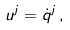<formula> <loc_0><loc_0><loc_500><loc_500>u ^ { j } = { \dot { q } } ^ { j } \, ,</formula> 